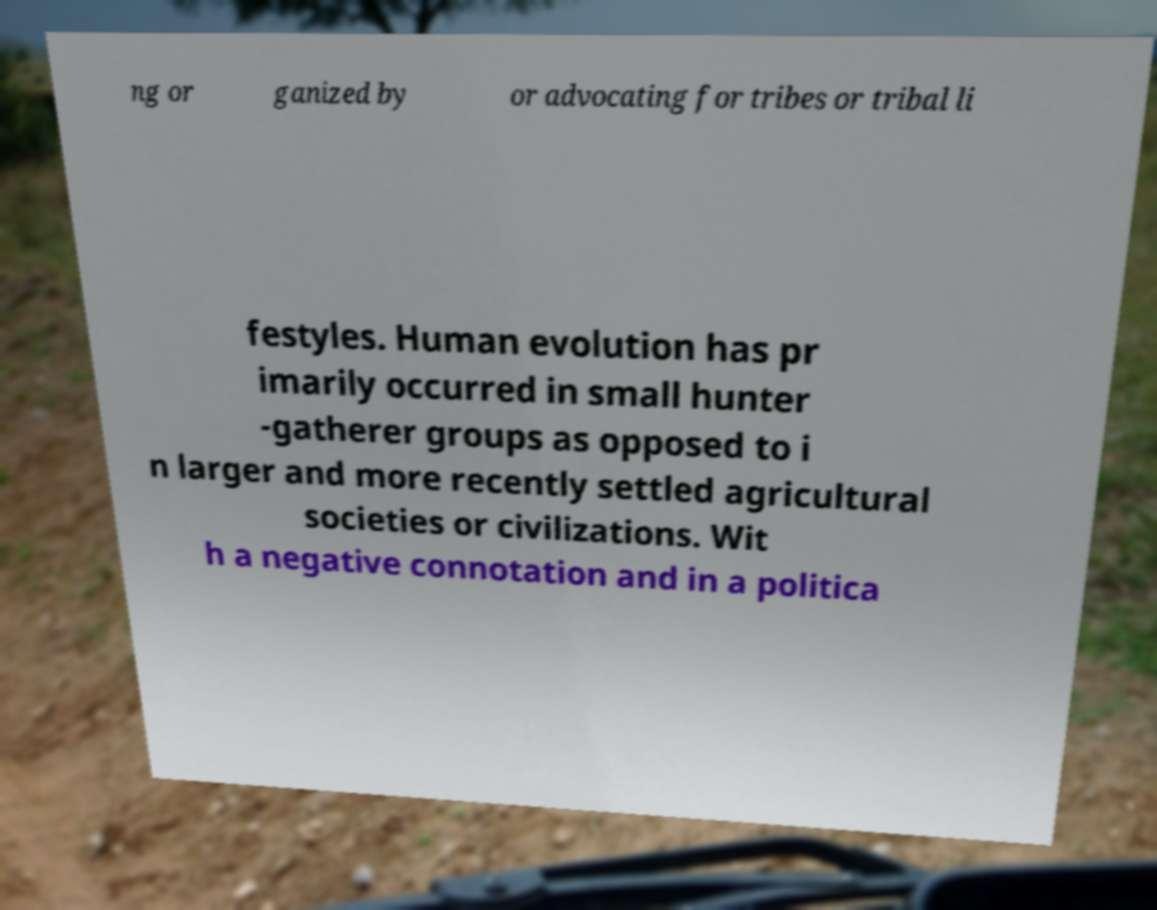Can you read and provide the text displayed in the image?This photo seems to have some interesting text. Can you extract and type it out for me? ng or ganized by or advocating for tribes or tribal li festyles. Human evolution has pr imarily occurred in small hunter -gatherer groups as opposed to i n larger and more recently settled agricultural societies or civilizations. Wit h a negative connotation and in a politica 